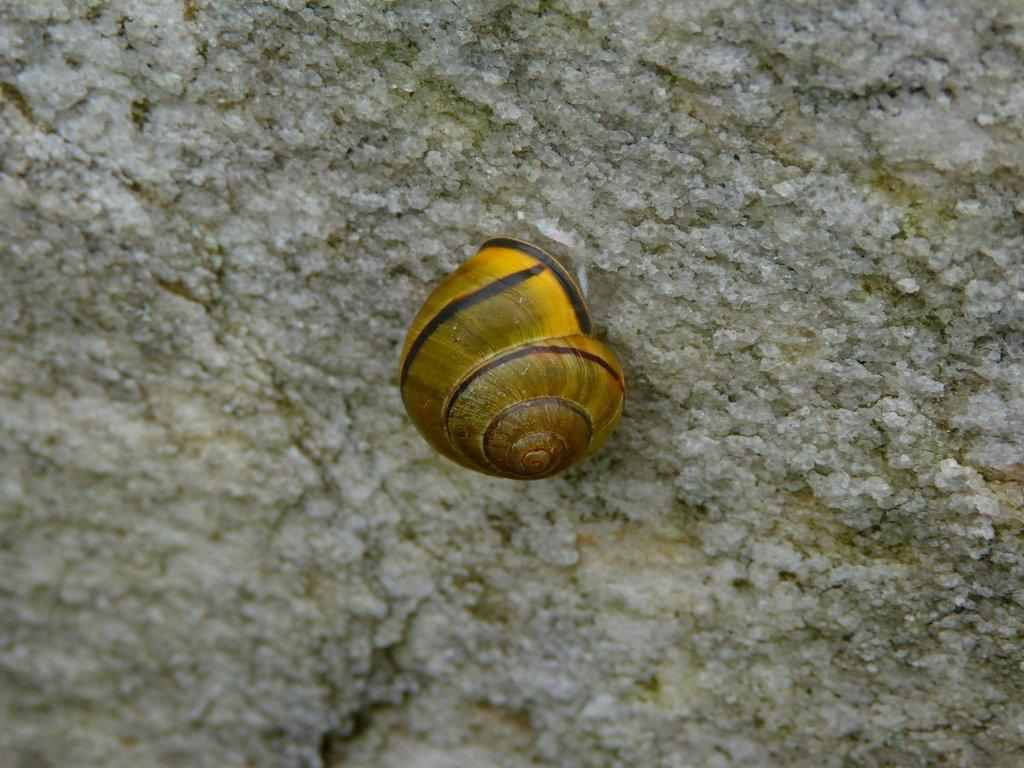What is the main object in the image? There is a shell in the image. Where is the shell located? The shell is on a surface. What event is taking place in the image involving the shell? There is no event involving the shell in the image; it is simply a shell on a surface. Is there any indication of death related to the shell in the image? No, there is no indication of death related to the shell in the image. 